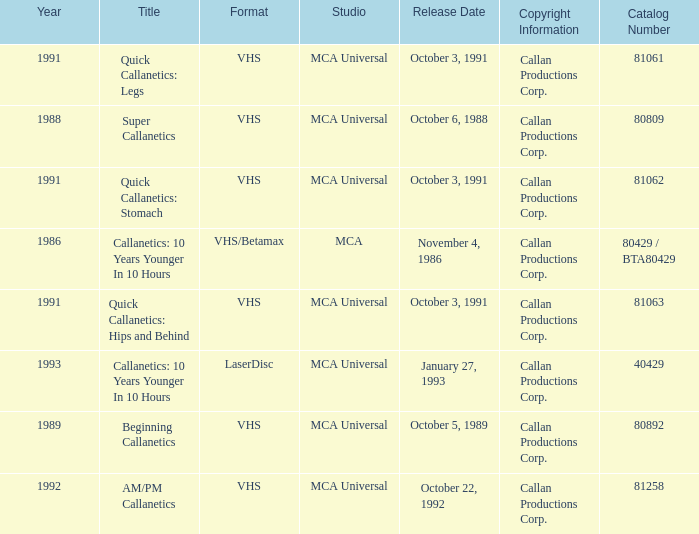Name the format for  quick callanetics: hips and behind VHS. 